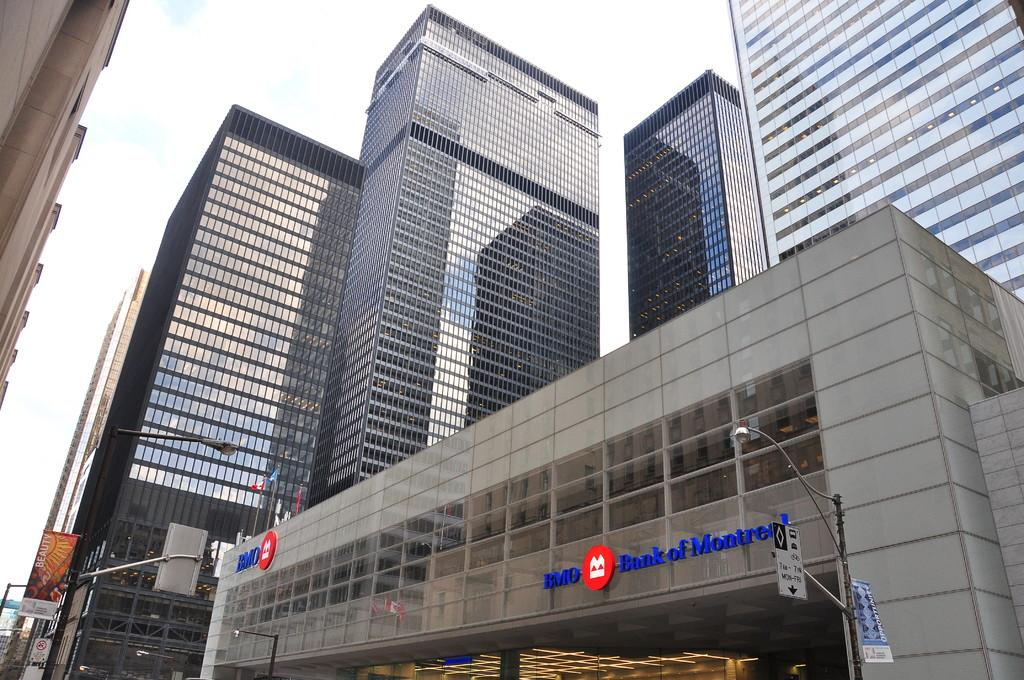<image>
Provide a brief description of the given image. a building with a sign on it that says 'bank of montreal' 